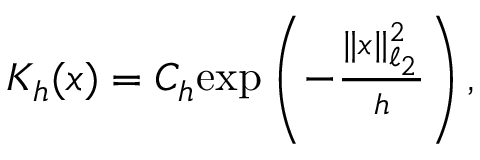<formula> <loc_0><loc_0><loc_500><loc_500>\begin{array} { r } { K _ { h } ( x ) = C _ { h } e x p \left ( - \frac { \| x \| _ { \ell _ { 2 } } ^ { 2 } } { h } \right ) , } \end{array}</formula> 